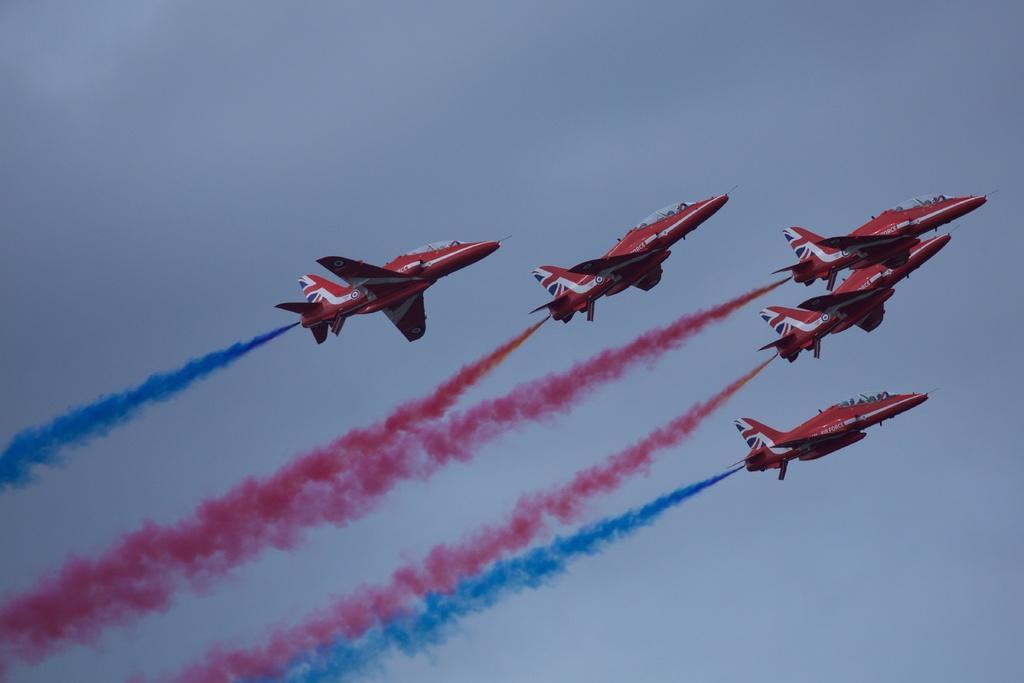Could you give a brief overview of what you see in this image? In this image I can see there are few rockets visible in the sky and I can see a colorful fog visible in the sky and in the background I can see the sky. 